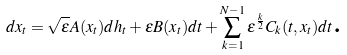Convert formula to latex. <formula><loc_0><loc_0><loc_500><loc_500>d x _ { t } = \sqrt { \varepsilon } A ( x _ { t } ) d h _ { t } + \varepsilon B ( x _ { t } ) d t + \sum _ { k = 1 } ^ { N - 1 } \varepsilon ^ { \frac { k } { 2 } } C _ { k } ( t , x _ { t } ) d t \text {.}</formula> 